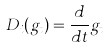Convert formula to latex. <formula><loc_0><loc_0><loc_500><loc_500>D _ { i } ( g _ { t } ) = \frac { d } { d t } g _ { t }</formula> 